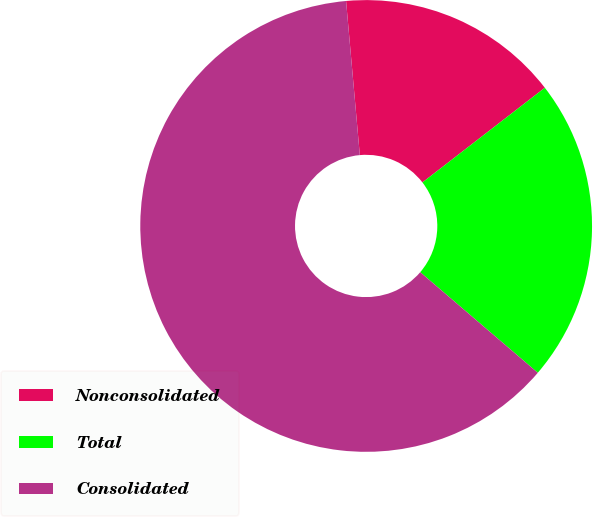Convert chart to OTSL. <chart><loc_0><loc_0><loc_500><loc_500><pie_chart><fcel>Nonconsolidated<fcel>Total<fcel>Consolidated<nl><fcel>15.94%<fcel>21.74%<fcel>62.32%<nl></chart> 